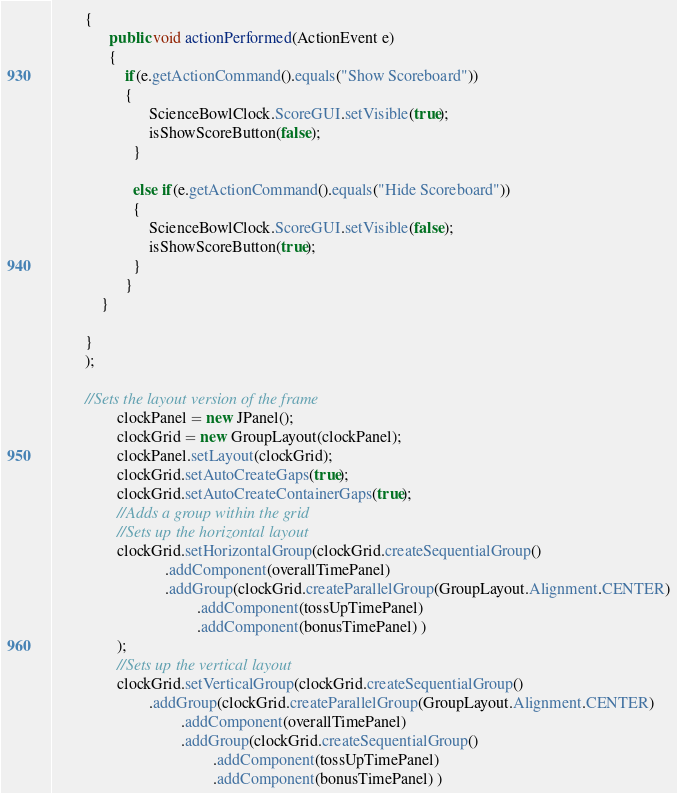Convert code to text. <code><loc_0><loc_0><loc_500><loc_500><_Java_>		{ 
			  public void actionPerformed(ActionEvent e) 
			  { 
				  if(e.getActionCommand().equals("Show Scoreboard"))
				  {
						ScienceBowlClock.ScoreGUI.setVisible(true);
						isShowScoreButton(false);
					}
					
					else if(e.getActionCommand().equals("Hide Scoreboard"))
					{
						ScienceBowlClock.ScoreGUI.setVisible(false);
						isShowScoreButton(true);
					}
				  } 
			} 
		
		}
		);
		
		//Sets the layout version of the frame
				clockPanel = new JPanel();
				clockGrid = new GroupLayout(clockPanel);
				clockPanel.setLayout(clockGrid);
				clockGrid.setAutoCreateGaps(true);
				clockGrid.setAutoCreateContainerGaps(true);
				//Adds a group within the grid
				//Sets up the horizontal layout
				clockGrid.setHorizontalGroup(clockGrid.createSequentialGroup()
							.addComponent(overallTimePanel)
							.addGroup(clockGrid.createParallelGroup(GroupLayout.Alignment.CENTER)
									.addComponent(tossUpTimePanel)
									.addComponent(bonusTimePanel) )
				);
				//Sets up the vertical layout
				clockGrid.setVerticalGroup(clockGrid.createSequentialGroup()
						.addGroup(clockGrid.createParallelGroup(GroupLayout.Alignment.CENTER)
								.addComponent(overallTimePanel)
								.addGroup(clockGrid.createSequentialGroup()
										.addComponent(tossUpTimePanel)
										.addComponent(bonusTimePanel) )</code> 